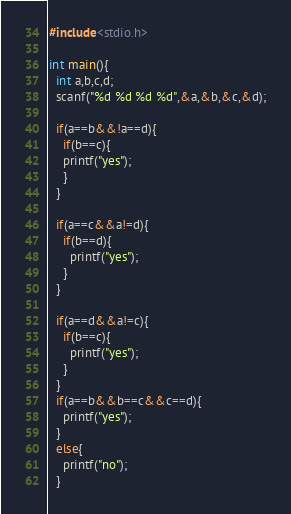<code> <loc_0><loc_0><loc_500><loc_500><_C_>#include<stdio.h>

int main(){
  int a,b,c,d;
  scanf("%d %d %d %d",&a,&b,&c,&d);

  if(a==b&&!a==d){
    if(b==c){
    printf("yes");
    }
  }

  if(a==c&&a!=d){
    if(b==d){
      printf("yes");
    }
  }

  if(a==d&&a!=c){
    if(b==c){
      printf("yes");
    }
  }
  if(a==b&&b==c&&c==d){
    printf("yes");
  }
  else{
    printf("no");
  }</code> 